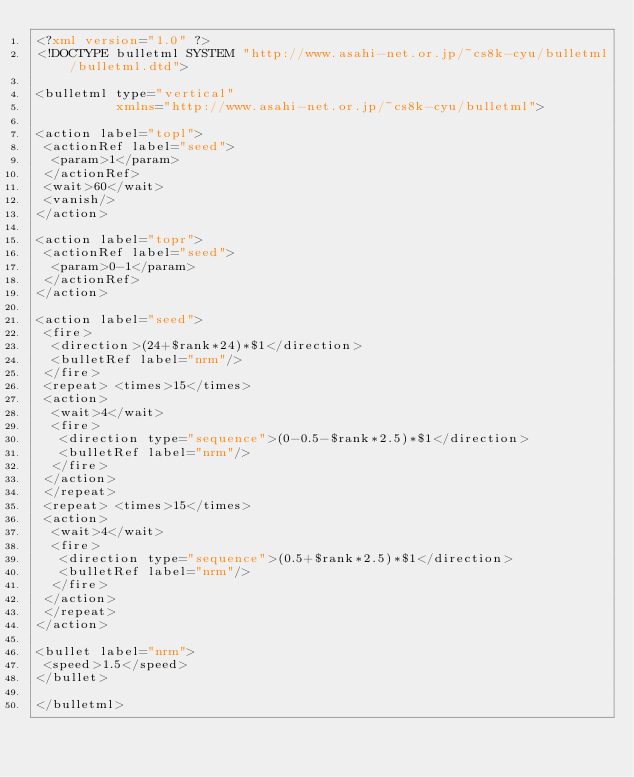<code> <loc_0><loc_0><loc_500><loc_500><_XML_><?xml version="1.0" ?>
<!DOCTYPE bulletml SYSTEM "http://www.asahi-net.or.jp/~cs8k-cyu/bulletml/bulletml.dtd">

<bulletml type="vertical"
          xmlns="http://www.asahi-net.or.jp/~cs8k-cyu/bulletml">

<action label="topl">
 <actionRef label="seed">
  <param>1</param>
 </actionRef>
 <wait>60</wait>
 <vanish/>
</action>

<action label="topr">
 <actionRef label="seed">
  <param>0-1</param>
 </actionRef>
</action>

<action label="seed">
 <fire>
  <direction>(24+$rank*24)*$1</direction>
  <bulletRef label="nrm"/>
 </fire>
 <repeat> <times>15</times>
 <action>
  <wait>4</wait>
  <fire>
   <direction type="sequence">(0-0.5-$rank*2.5)*$1</direction>
   <bulletRef label="nrm"/>
  </fire>
 </action>
 </repeat>
 <repeat> <times>15</times>
 <action>
  <wait>4</wait>
  <fire>
   <direction type="sequence">(0.5+$rank*2.5)*$1</direction>
   <bulletRef label="nrm"/>
  </fire>
 </action>
 </repeat>
</action>

<bullet label="nrm">
 <speed>1.5</speed>
</bullet>

</bulletml>
</code> 